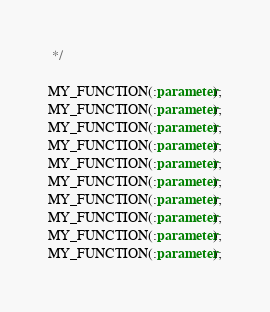<code> <loc_0><loc_0><loc_500><loc_500><_SQL_> */

MY_FUNCTION(:parameter);
MY_FUNCTION(:parameter);
MY_FUNCTION(:parameter);
MY_FUNCTION(:parameter);
MY_FUNCTION(:parameter);
MY_FUNCTION(:parameter);
MY_FUNCTION(:parameter);
MY_FUNCTION(:parameter);
MY_FUNCTION(:parameter);
MY_FUNCTION(:parameter);
</code> 